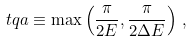Convert formula to latex. <formula><loc_0><loc_0><loc_500><loc_500>\ t q a \equiv \max \left ( \frac { \pi } { 2 E } , \frac { \pi } { 2 \Delta E } \right ) \, ,</formula> 